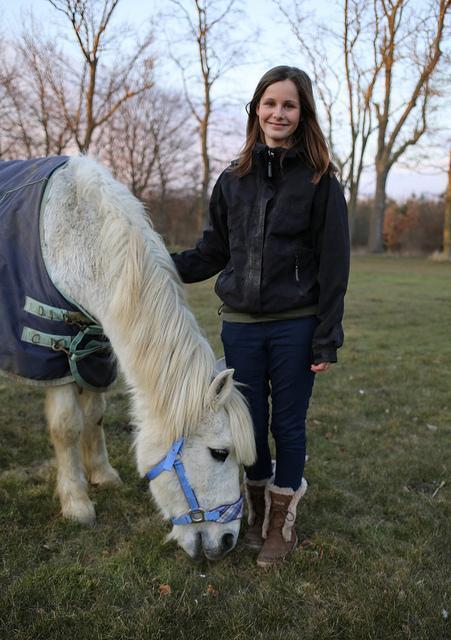How many horses are in the picture?
Give a very brief answer. 1. 